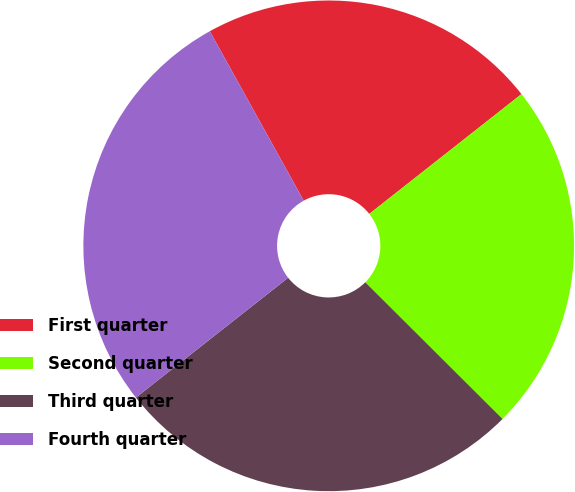Convert chart to OTSL. <chart><loc_0><loc_0><loc_500><loc_500><pie_chart><fcel>First quarter<fcel>Second quarter<fcel>Third quarter<fcel>Fourth quarter<nl><fcel>22.44%<fcel>23.08%<fcel>26.92%<fcel>27.56%<nl></chart> 